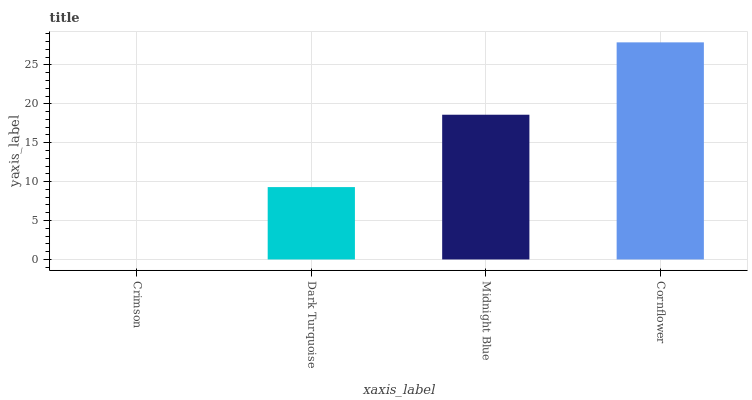Is Crimson the minimum?
Answer yes or no. Yes. Is Cornflower the maximum?
Answer yes or no. Yes. Is Dark Turquoise the minimum?
Answer yes or no. No. Is Dark Turquoise the maximum?
Answer yes or no. No. Is Dark Turquoise greater than Crimson?
Answer yes or no. Yes. Is Crimson less than Dark Turquoise?
Answer yes or no. Yes. Is Crimson greater than Dark Turquoise?
Answer yes or no. No. Is Dark Turquoise less than Crimson?
Answer yes or no. No. Is Midnight Blue the high median?
Answer yes or no. Yes. Is Dark Turquoise the low median?
Answer yes or no. Yes. Is Crimson the high median?
Answer yes or no. No. Is Cornflower the low median?
Answer yes or no. No. 